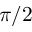Convert formula to latex. <formula><loc_0><loc_0><loc_500><loc_500>\pi / 2</formula> 